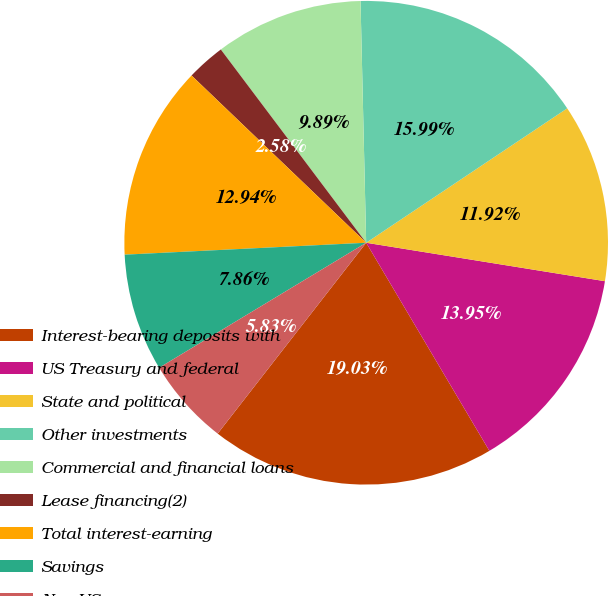Convert chart. <chart><loc_0><loc_0><loc_500><loc_500><pie_chart><fcel>Interest-bearing deposits with<fcel>US Treasury and federal<fcel>State and political<fcel>Other investments<fcel>Commercial and financial loans<fcel>Lease financing(2)<fcel>Total interest-earning<fcel>Savings<fcel>Non-US<nl><fcel>19.03%<fcel>13.95%<fcel>11.92%<fcel>15.99%<fcel>9.89%<fcel>2.58%<fcel>12.94%<fcel>7.86%<fcel>5.83%<nl></chart> 